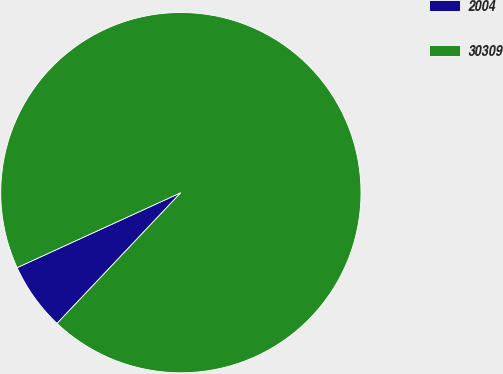<chart> <loc_0><loc_0><loc_500><loc_500><pie_chart><fcel>2004<fcel>30309<nl><fcel>6.1%<fcel>93.9%<nl></chart> 